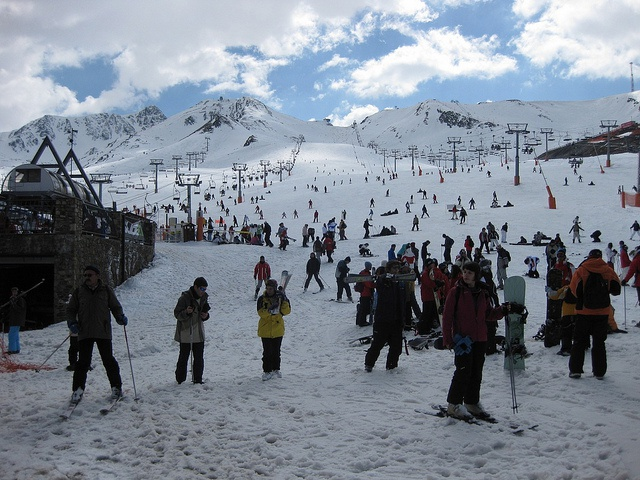Describe the objects in this image and their specific colors. I can see people in lightgray, black, darkgray, and gray tones, people in lightgray, black, and gray tones, people in lightgray, black, maroon, gray, and darkgray tones, people in lightgray, black, and gray tones, and people in lightgray, black, gray, and darkgray tones in this image. 